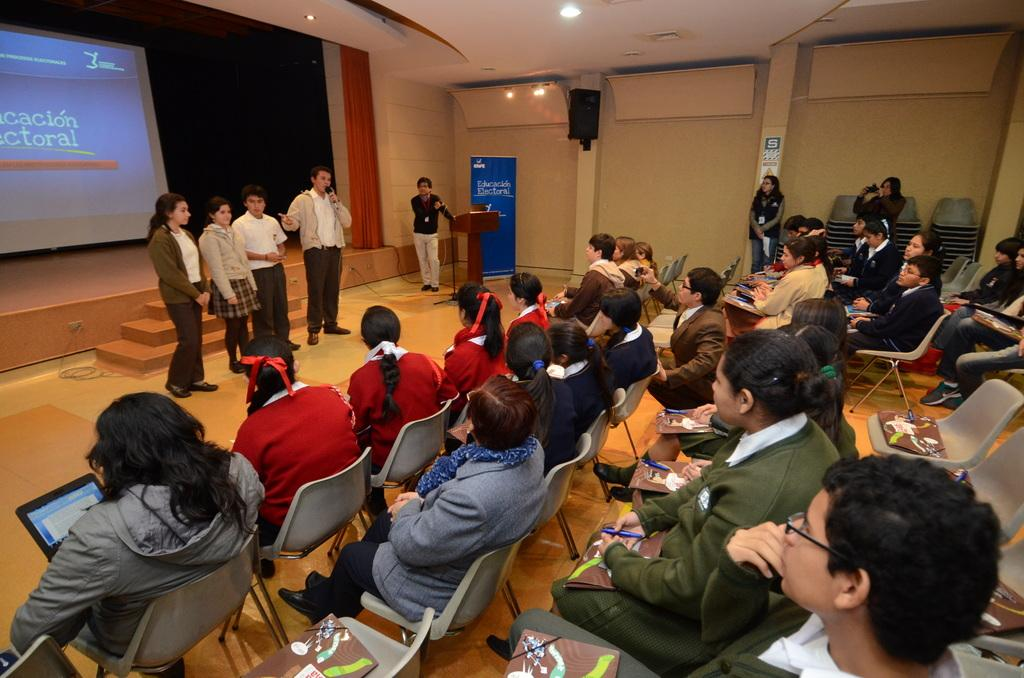How many people are in the image? There is a group of people in the image, but the exact number is not specified. What are some of the people in the image doing? Some people are sitting on chairs, and some people are standing. What can be seen near the people in the image? There is a podium in the image. What is visible in the background of the image? There is a wall and a roof in the background of the image. What is the color of the finger that is pointing at the wall in the image? There is no finger pointing at the wall in the image. 